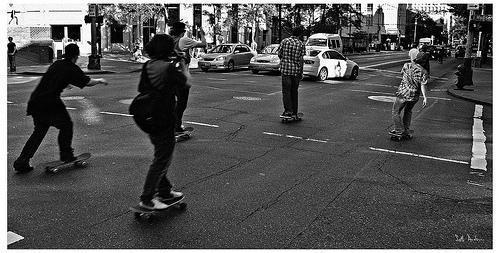How many motor vehicles are in the photo?
Give a very brief answer. 4. 